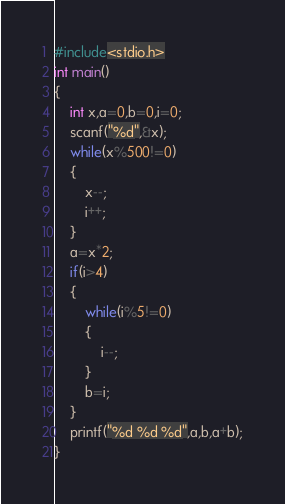<code> <loc_0><loc_0><loc_500><loc_500><_C_>#include<stdio.h>
int main()
{
    int x,a=0,b=0,i=0;
    scanf("%d",&x);
    while(x%500!=0)
    {
        x--;
        i++;
    }
    a=x*2;
    if(i>4)
    {
        while(i%5!=0)
        {
            i--;
        }
        b=i;
    }
    printf("%d %d %d",a,b,a+b);
}
</code> 